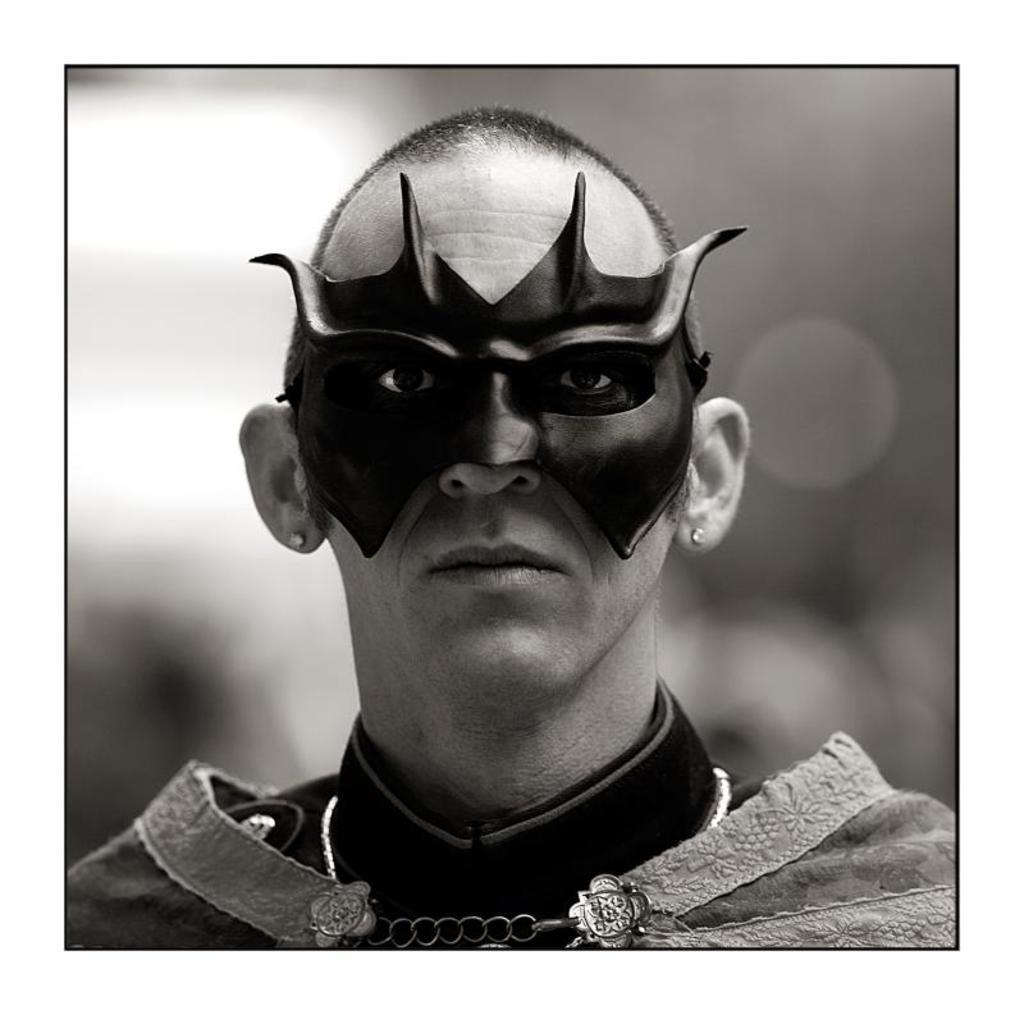Can you describe this image briefly? This image is a black and white image. In this image the background is a little blurred. In the middle of the image there is a man in a costume and there is a mask on his face. 